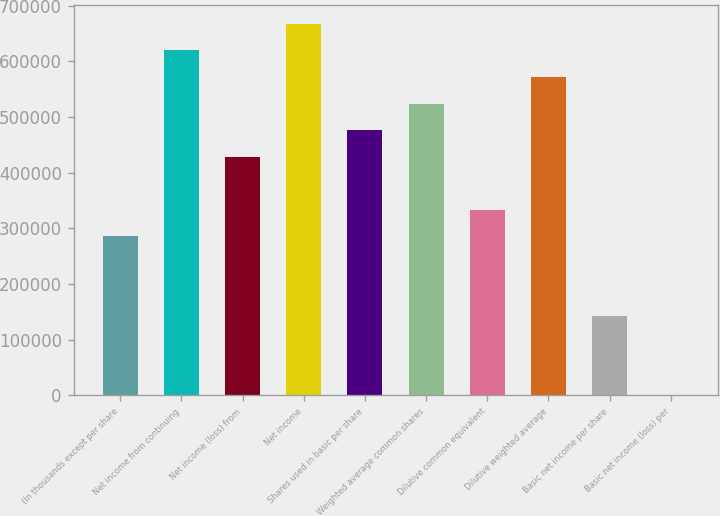Convert chart to OTSL. <chart><loc_0><loc_0><loc_500><loc_500><bar_chart><fcel>(In thousands except per share<fcel>Net income from continuing<fcel>Net income (loss) from<fcel>Net income<fcel>Shares used in basic per share<fcel>Weighted average common shares<fcel>Dilutive common equivalent<fcel>Dilutive weighted average<fcel>Basic net income per share<fcel>Basic net income (loss) per<nl><fcel>286057<fcel>619791<fcel>429086<fcel>667467<fcel>476762<fcel>524438<fcel>333733<fcel>572114<fcel>143029<fcel>0.08<nl></chart> 